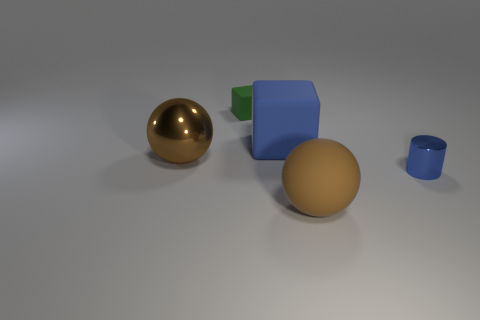How many matte objects are either brown balls or big cubes?
Provide a succinct answer. 2. What is the shape of the brown object to the left of the brown ball that is in front of the blue metallic cylinder?
Provide a succinct answer. Sphere. Does the sphere that is to the left of the small rubber thing have the same material as the ball that is in front of the cylinder?
Offer a terse response. No. There is a brown shiny ball that is left of the large blue matte block; what number of large matte objects are behind it?
Offer a terse response. 1. Is the shape of the large brown thing that is in front of the blue metallic cylinder the same as the metallic thing that is behind the tiny blue object?
Your response must be concise. Yes. There is a object that is in front of the large blue block and behind the small metal thing; how big is it?
Give a very brief answer. Large. The other matte thing that is the same shape as the green object is what color?
Your answer should be compact. Blue. What is the color of the large thing behind the large sphere behind the rubber sphere?
Your answer should be compact. Blue. There is a big blue object; what shape is it?
Provide a succinct answer. Cube. What shape is the thing that is in front of the big blue block and on the left side of the large brown rubber ball?
Your response must be concise. Sphere. 